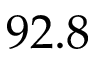Convert formula to latex. <formula><loc_0><loc_0><loc_500><loc_500>9 2 . 8</formula> 